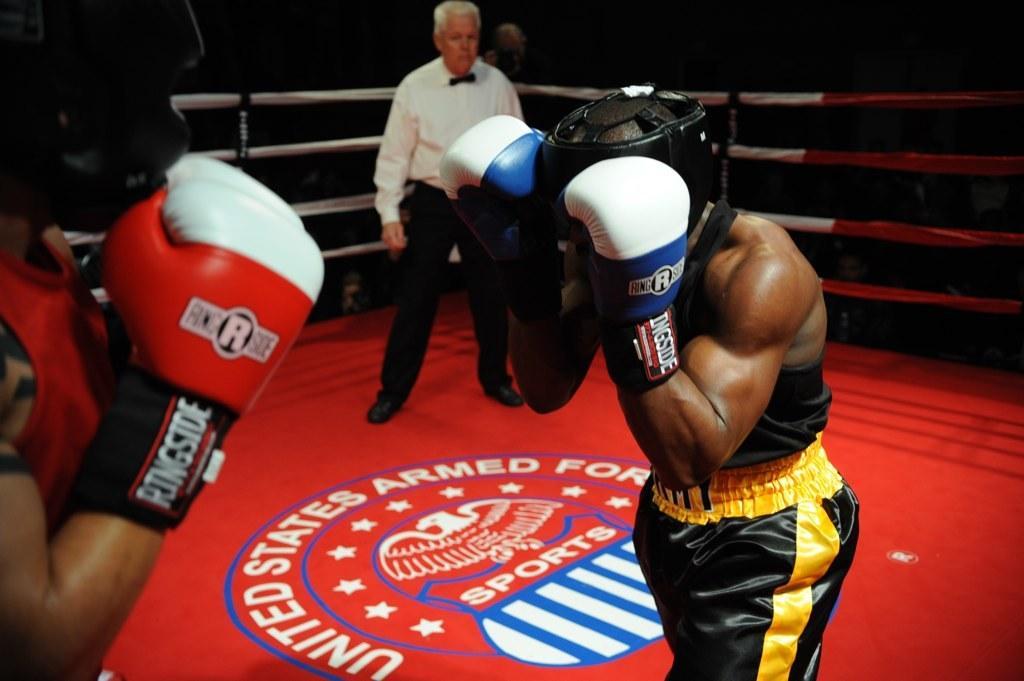Please provide a concise description of this image. Two people are boxing in the boxing field and behind them a man standing and watching their play. 